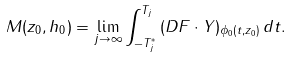Convert formula to latex. <formula><loc_0><loc_0><loc_500><loc_500>M ( z _ { 0 } , h _ { 0 } ) = \lim _ { j \to \infty } \int _ { - T _ { j } ^ { * } } ^ { T _ { j } } \, ( D F \cdot Y ) _ { \phi _ { 0 } ( t , z _ { 0 } ) } \, d t .</formula> 